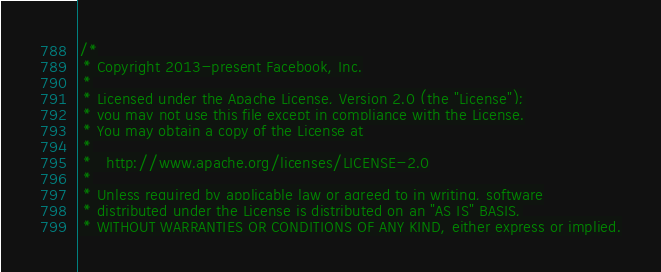Convert code to text. <code><loc_0><loc_0><loc_500><loc_500><_C++_>/*
 * Copyright 2013-present Facebook, Inc.
 *
 * Licensed under the Apache License, Version 2.0 (the "License");
 * you may not use this file except in compliance with the License.
 * You may obtain a copy of the License at
 *
 *   http://www.apache.org/licenses/LICENSE-2.0
 *
 * Unless required by applicable law or agreed to in writing, software
 * distributed under the License is distributed on an "AS IS" BASIS,
 * WITHOUT WARRANTIES OR CONDITIONS OF ANY KIND, either express or implied.</code> 